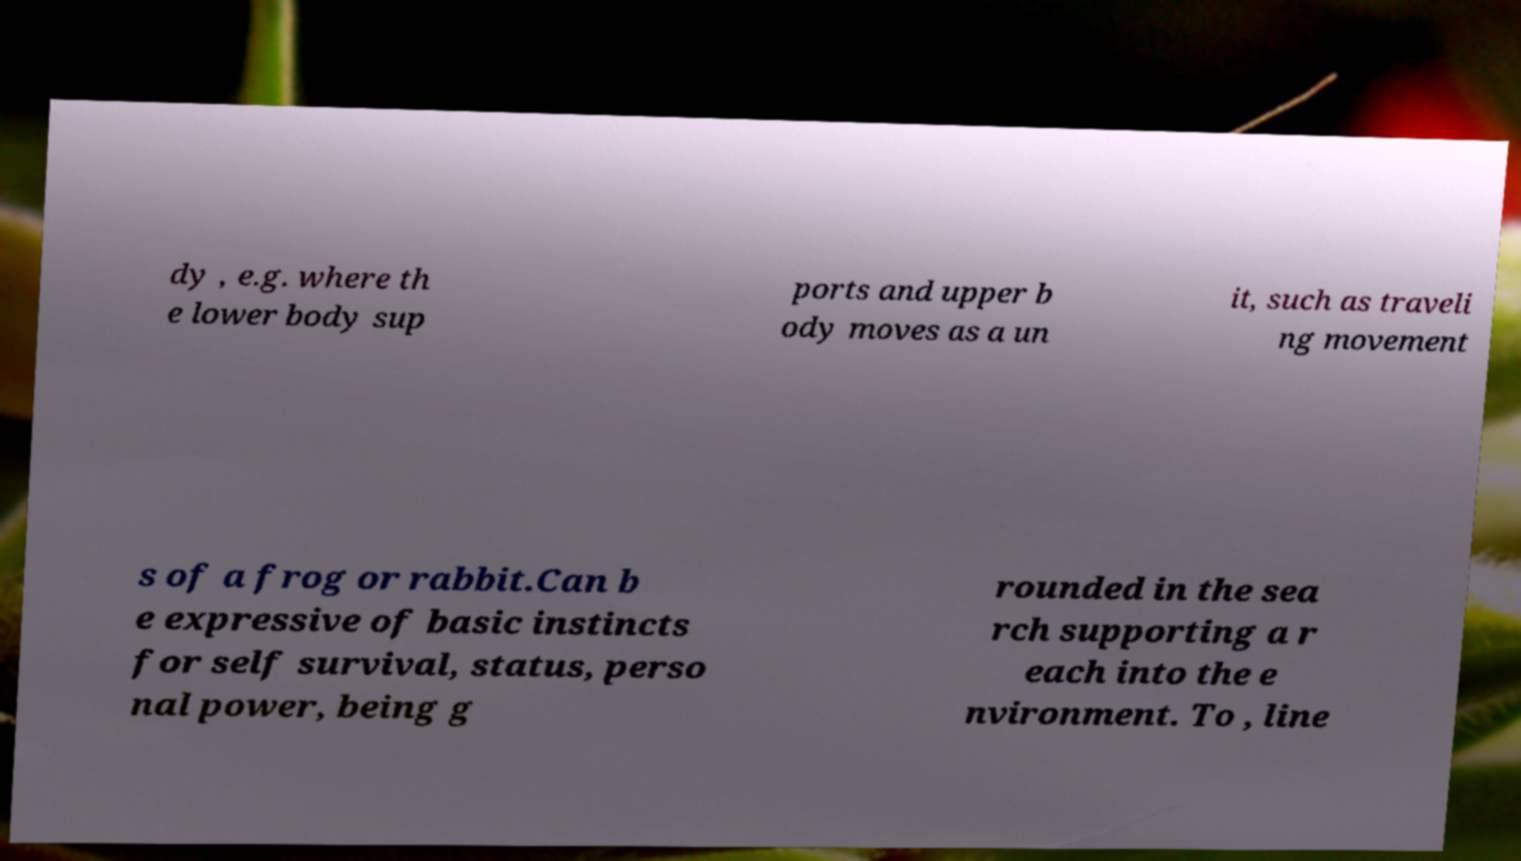I need the written content from this picture converted into text. Can you do that? dy , e.g. where th e lower body sup ports and upper b ody moves as a un it, such as traveli ng movement s of a frog or rabbit.Can b e expressive of basic instincts for self survival, status, perso nal power, being g rounded in the sea rch supporting a r each into the e nvironment. To , line 